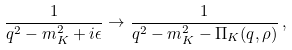<formula> <loc_0><loc_0><loc_500><loc_500>\frac { 1 } { q ^ { 2 } - m _ { K } ^ { 2 } + i \epsilon } \rightarrow \frac { 1 } { q ^ { 2 } - m _ { K } ^ { 2 } - \Pi _ { K } ( q , \rho ) } \, ,</formula> 